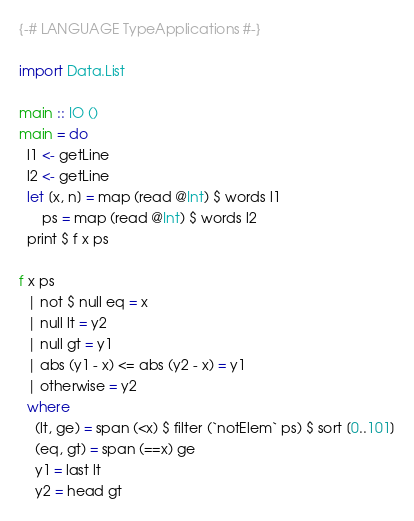Convert code to text. <code><loc_0><loc_0><loc_500><loc_500><_Haskell_>{-# LANGUAGE TypeApplications #-}

import Data.List

main :: IO ()
main = do
  l1 <- getLine
  l2 <- getLine
  let [x, n] = map (read @Int) $ words l1
      ps = map (read @Int) $ words l2
  print $ f x ps

f x ps
  | not $ null eq = x
  | null lt = y2
  | null gt = y1
  | abs (y1 - x) <= abs (y2 - x) = y1
  | otherwise = y2
  where
    (lt, ge) = span (<x) $ filter (`notElem` ps) $ sort [0..101]
    (eq, gt) = span (==x) ge
    y1 = last lt
    y2 = head gt
</code> 